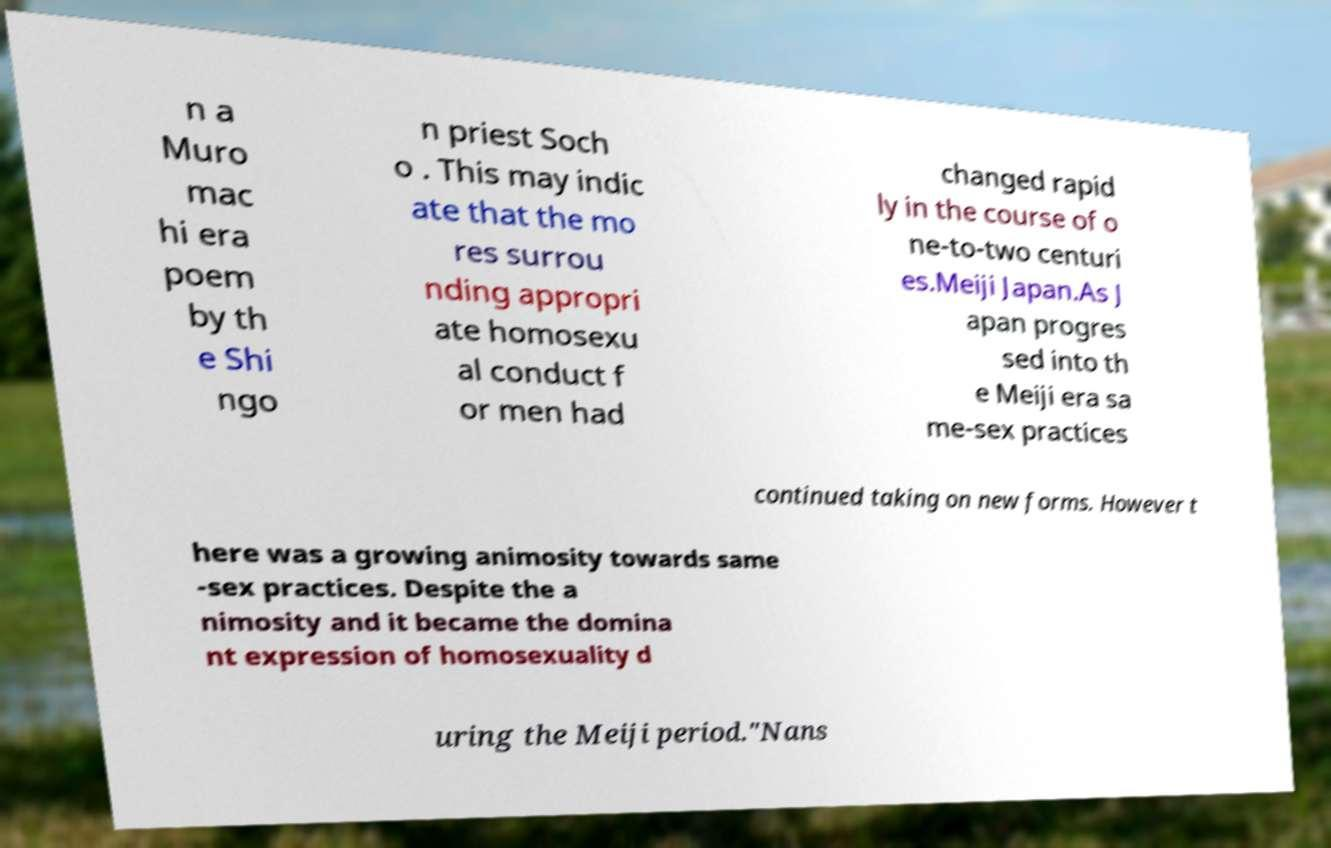Please read and relay the text visible in this image. What does it say? n a Muro mac hi era poem by th e Shi ngo n priest Soch o . This may indic ate that the mo res surrou nding appropri ate homosexu al conduct f or men had changed rapid ly in the course of o ne-to-two centuri es.Meiji Japan.As J apan progres sed into th e Meiji era sa me-sex practices continued taking on new forms. However t here was a growing animosity towards same -sex practices. Despite the a nimosity and it became the domina nt expression of homosexuality d uring the Meiji period."Nans 